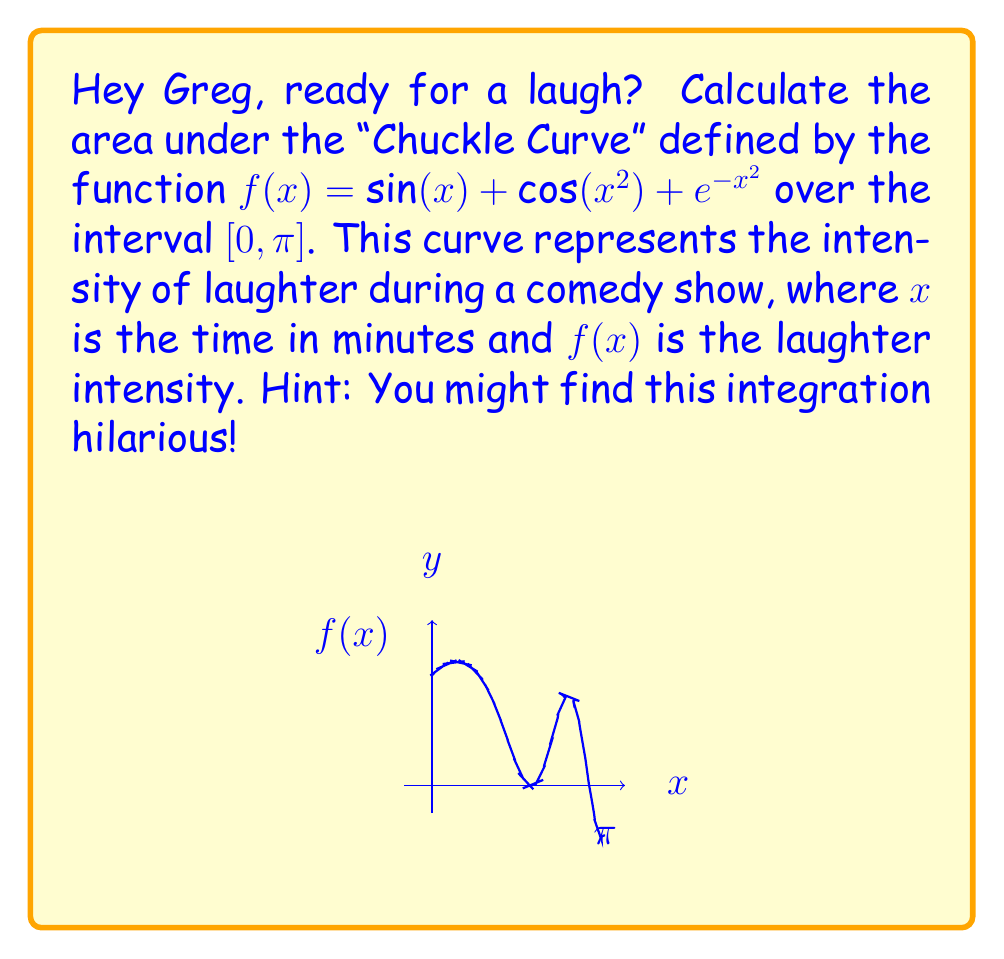Provide a solution to this math problem. Let's approach this step by step, Greg. Remember, laughter is the best medicine, but integration is a close second!

1) We need to integrate $f(x) = \sin(x) + \cos(x^2) + e^{-x^2}$ from 0 to $\pi$. 
   
   $$\int_0^{\pi} (\sin(x) + \cos(x^2) + e^{-x^2}) dx$$

2) We can split this into three integrals:
   
   $$\int_0^{\pi} \sin(x) dx + \int_0^{\pi} \cos(x^2) dx + \int_0^{\pi} e^{-x^2} dx$$

3) Let's solve each integral:

   a) $\int_0^{\pi} \sin(x) dx = [-\cos(x)]_0^{\pi} = -\cos(\pi) - (-\cos(0)) = 1 + 1 = 2$

   b) For $\int_0^{\pi} \cos(x^2) dx$, we can't solve this analytically. We'll leave it as is.

   c) $\int_0^{\pi} e^{-x^2} dx$ is also not analytically solvable. We'll leave it as is too.

4) Our result is:

   $$2 + \int_0^{\pi} \cos(x^2) dx + \int_0^{\pi} e^{-x^2} dx$$

5) The integrals in (b) and (c) can be evaluated numerically:
   
   $\int_0^{\pi} \cos(x^2) dx \approx 0.6227$
   $\int_0^{\pi} e^{-x^2} dx \approx 0.8862$

6) Adding all parts:

   $2 + 0.6227 + 0.8862 \approx 3.5089$

And there you have it, Greg! The area under the "Chuckle Curve" is approximately 3.5089 laugh-units. That's a pretty good comedy show!
Answer: $2 + \int_0^{\pi} \cos(x^2) dx + \int_0^{\pi} e^{-x^2} dx \approx 3.5089$ 